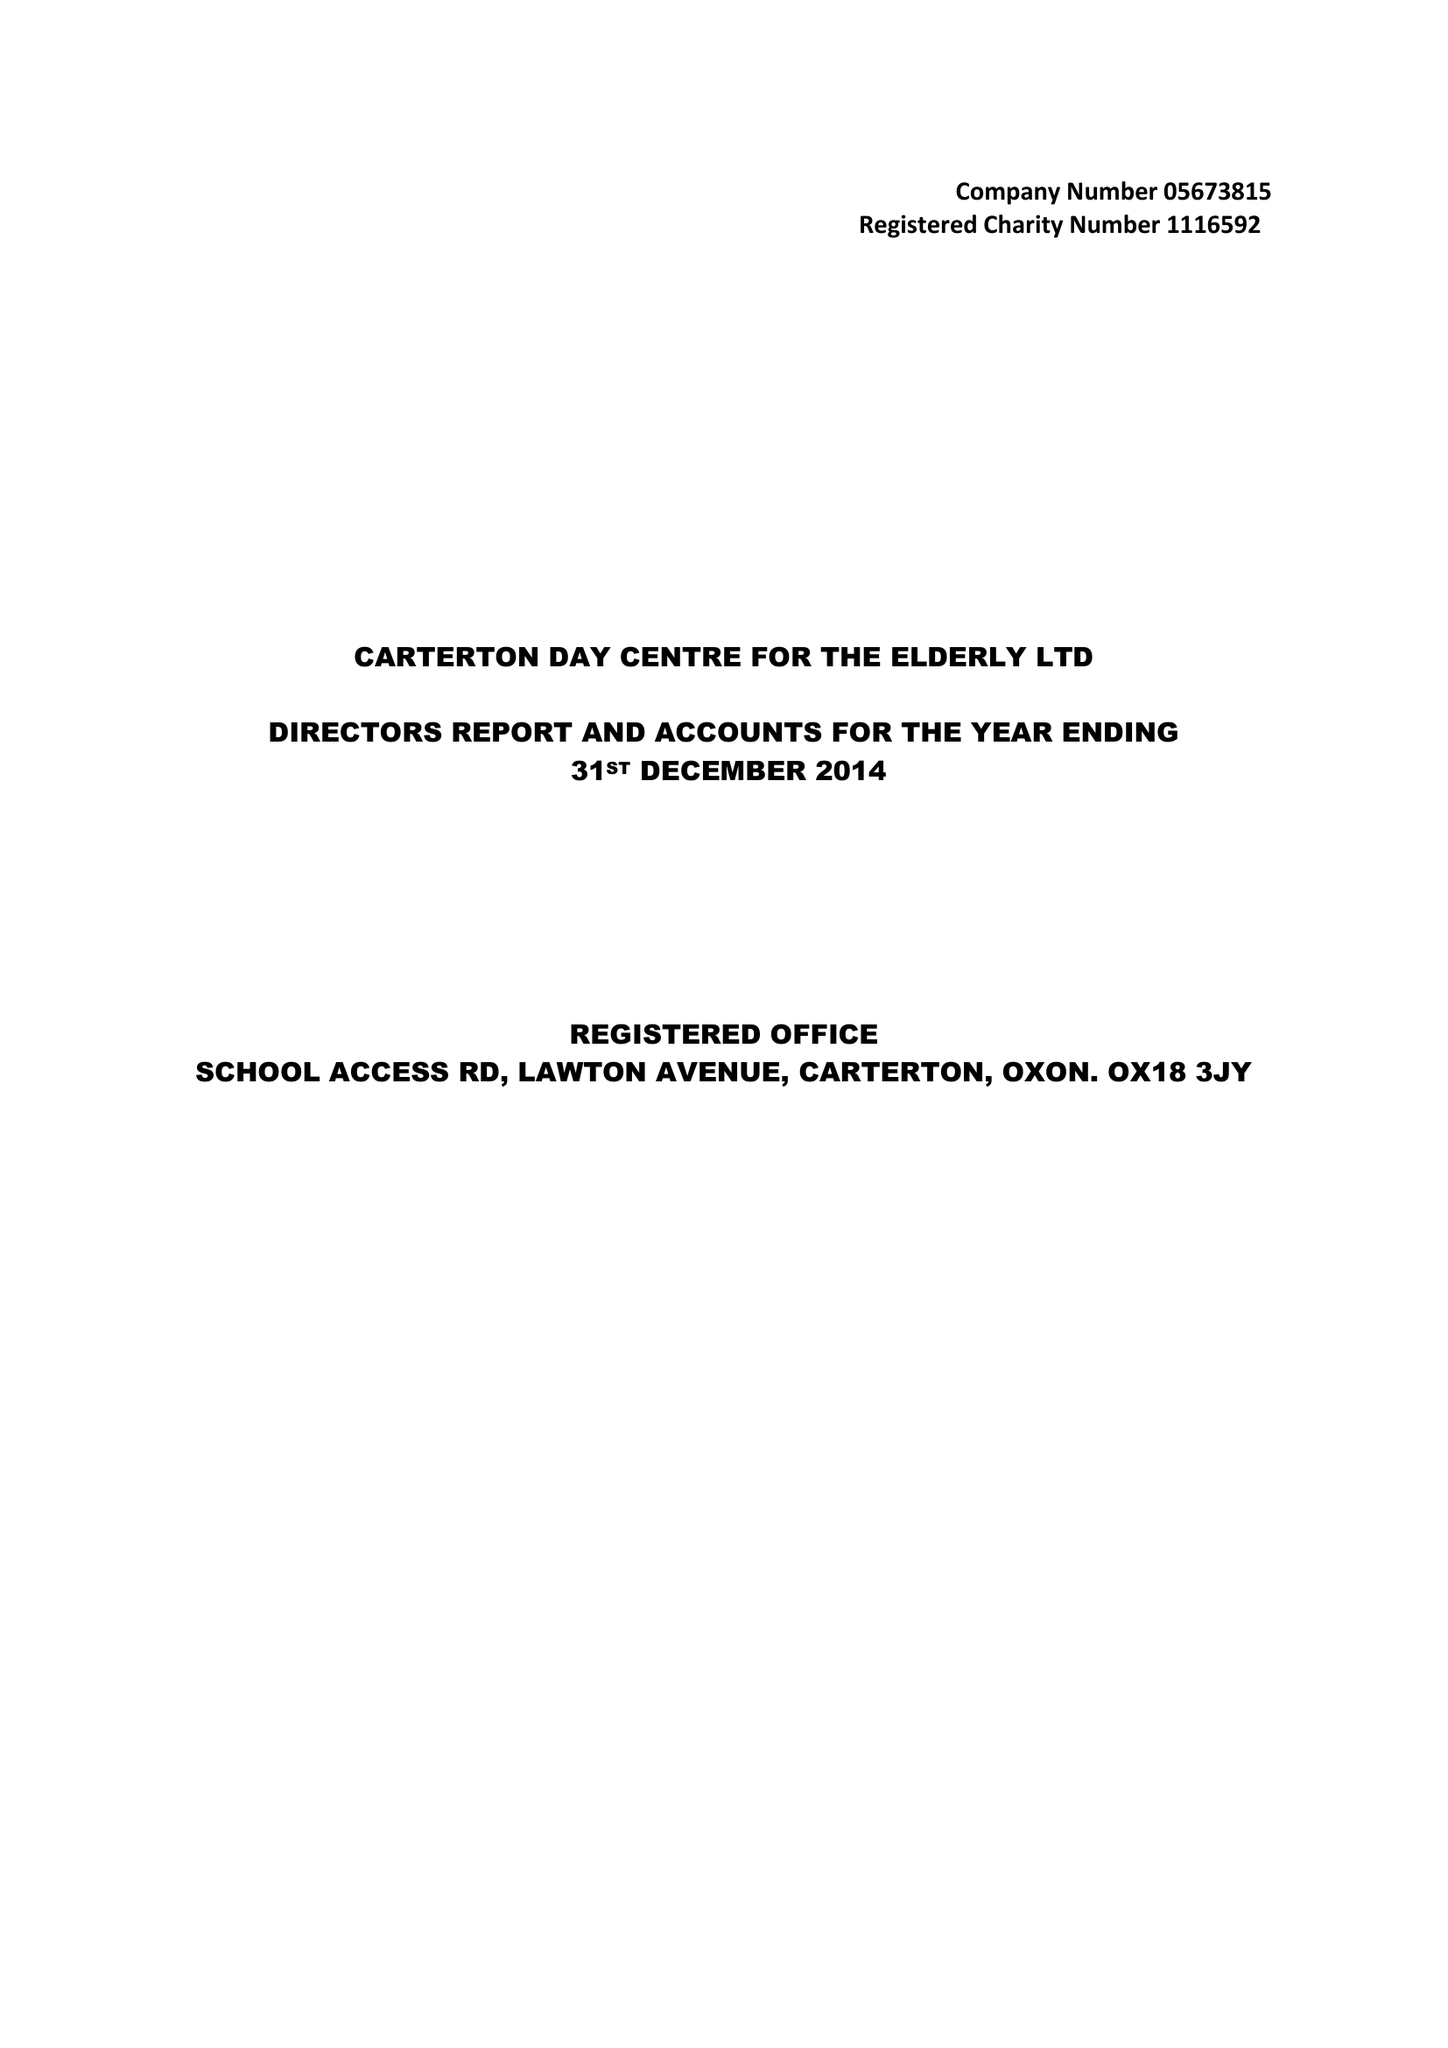What is the value for the charity_name?
Answer the question using a single word or phrase. Carterton Day Centre For The Elderly Ltd. 